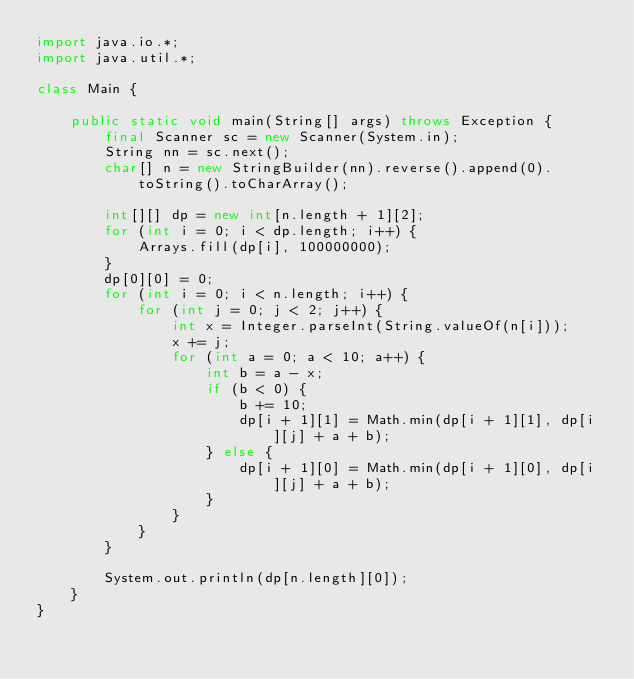Convert code to text. <code><loc_0><loc_0><loc_500><loc_500><_Java_>import java.io.*;
import java.util.*;

class Main {

	public static void main(String[] args) throws Exception {
		final Scanner sc = new Scanner(System.in);
		String nn = sc.next();
		char[] n = new StringBuilder(nn).reverse().append(0).toString().toCharArray();

		int[][] dp = new int[n.length + 1][2];
		for (int i = 0; i < dp.length; i++) {
			Arrays.fill(dp[i], 100000000);
		}
		dp[0][0] = 0;
		for (int i = 0; i < n.length; i++) {
			for (int j = 0; j < 2; j++) {
				int x = Integer.parseInt(String.valueOf(n[i]));
				x += j;
				for (int a = 0; a < 10; a++) {
					int b = a - x;
					if (b < 0) {
						b += 10;
						dp[i + 1][1] = Math.min(dp[i + 1][1], dp[i][j] + a + b);
					} else {
						dp[i + 1][0] = Math.min(dp[i + 1][0], dp[i][j] + a + b);
					}
				}
			}
		}

		System.out.println(dp[n.length][0]);
	}
}
</code> 